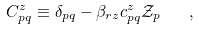<formula> <loc_0><loc_0><loc_500><loc_500>C ^ { z } _ { p q } \equiv \delta _ { p q } - \beta _ { r z } c ^ { z } _ { p q } { \mathcal { Z } } _ { p } \quad ,</formula> 